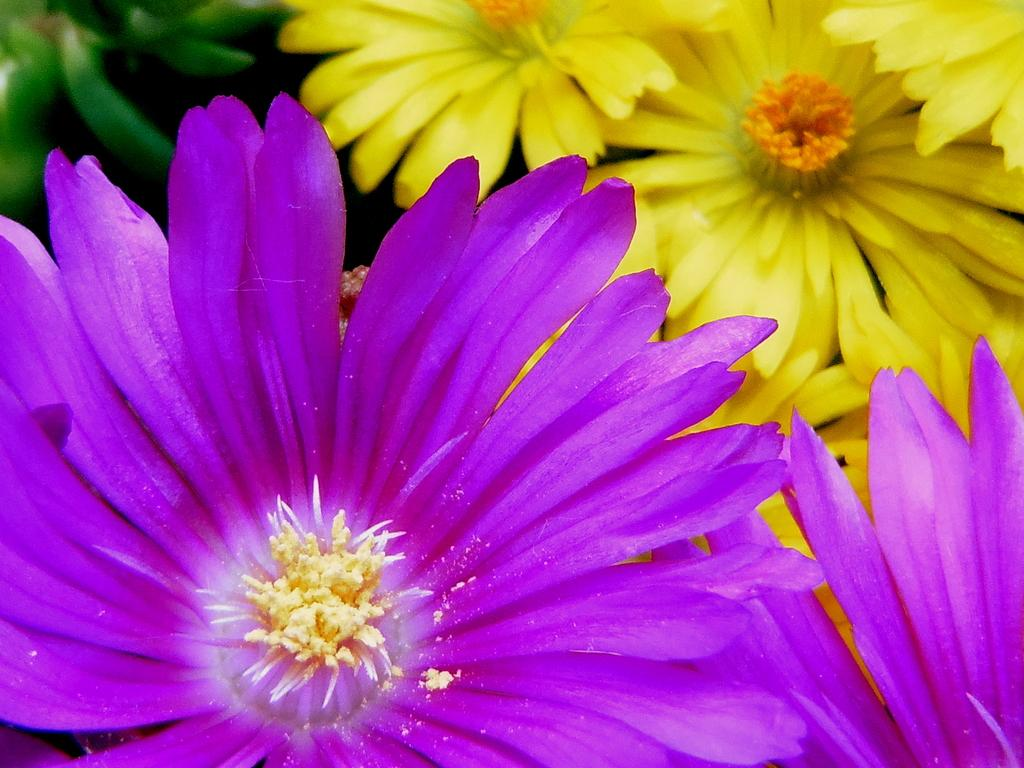What type of objects are present in the image? There are flowers in the image. What colors can be seen in the flowers? The flowers are in yellow and violet colors. What brand of toothpaste is being advertised by the flowers in the image? There is no toothpaste or advertisement present in the image; it features flowers in yellow and violet colors. How many cattle can be seen grazing in the field in the image? There are no cattle or fields present in the image; it features flowers in yellow and violet colors. 